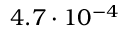Convert formula to latex. <formula><loc_0><loc_0><loc_500><loc_500>4 . 7 \cdot 1 0 ^ { - 4 }</formula> 